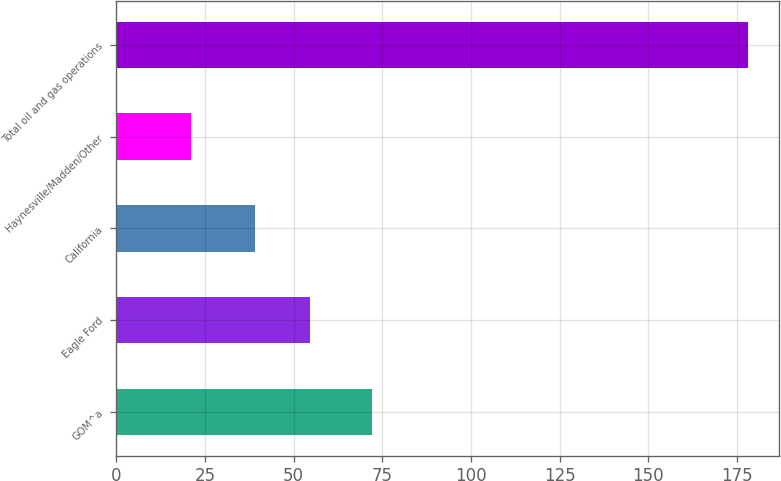Convert chart to OTSL. <chart><loc_0><loc_0><loc_500><loc_500><bar_chart><fcel>GOM^a<fcel>Eagle Ford<fcel>California<fcel>Haynesville/Madden/Other<fcel>Total oil and gas operations<nl><fcel>72<fcel>54.7<fcel>39<fcel>21<fcel>178<nl></chart> 